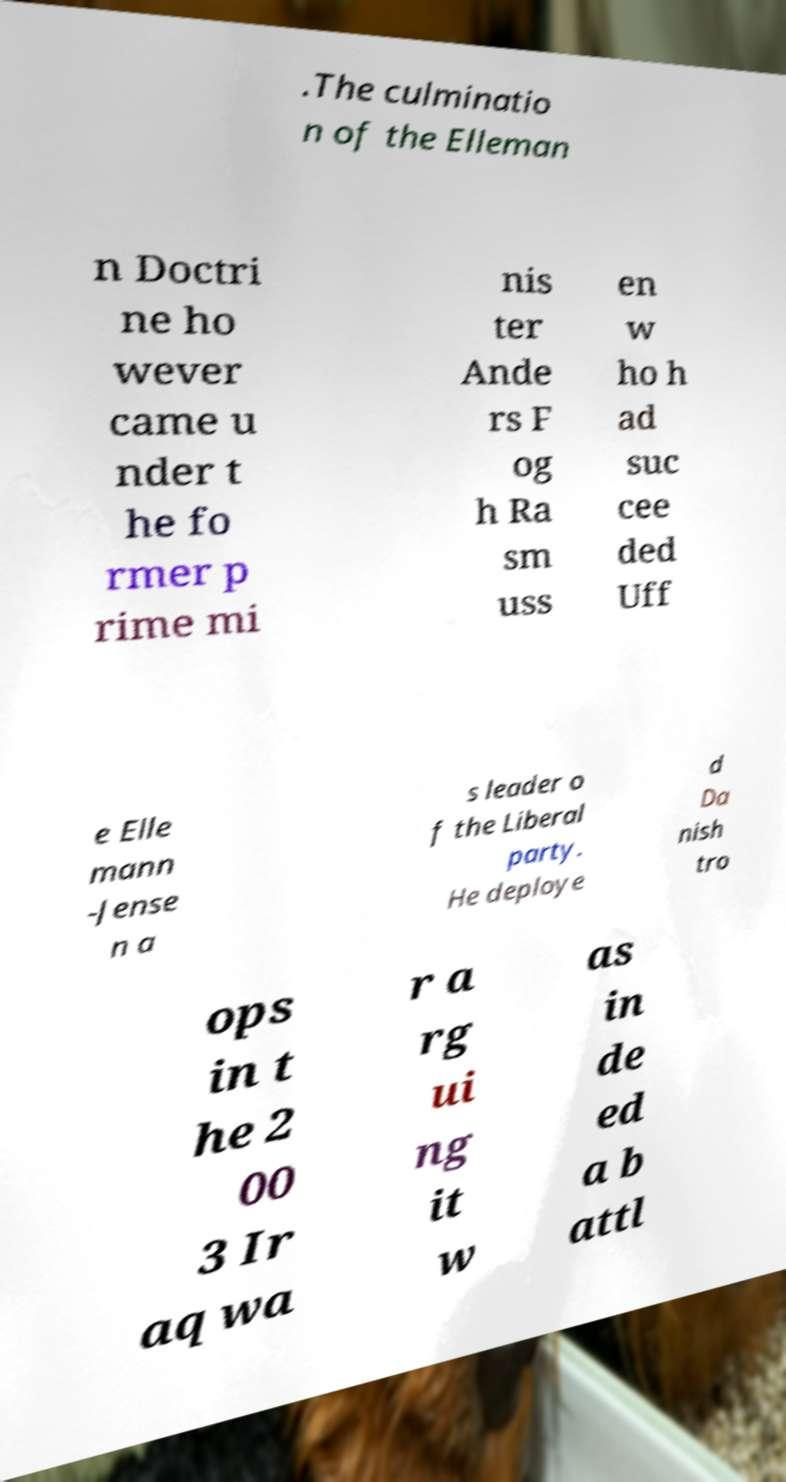There's text embedded in this image that I need extracted. Can you transcribe it verbatim? .The culminatio n of the Elleman n Doctri ne ho wever came u nder t he fo rmer p rime mi nis ter Ande rs F og h Ra sm uss en w ho h ad suc cee ded Uff e Elle mann -Jense n a s leader o f the Liberal party. He deploye d Da nish tro ops in t he 2 00 3 Ir aq wa r a rg ui ng it w as in de ed a b attl 